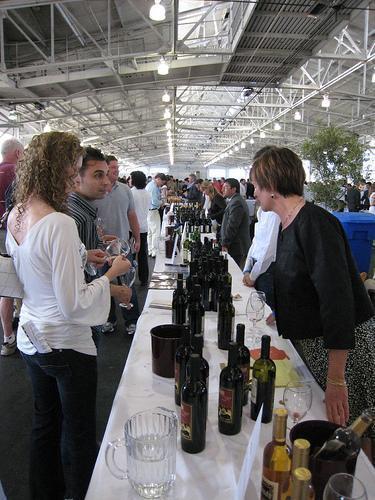How many people can be seen?
Give a very brief answer. 4. 